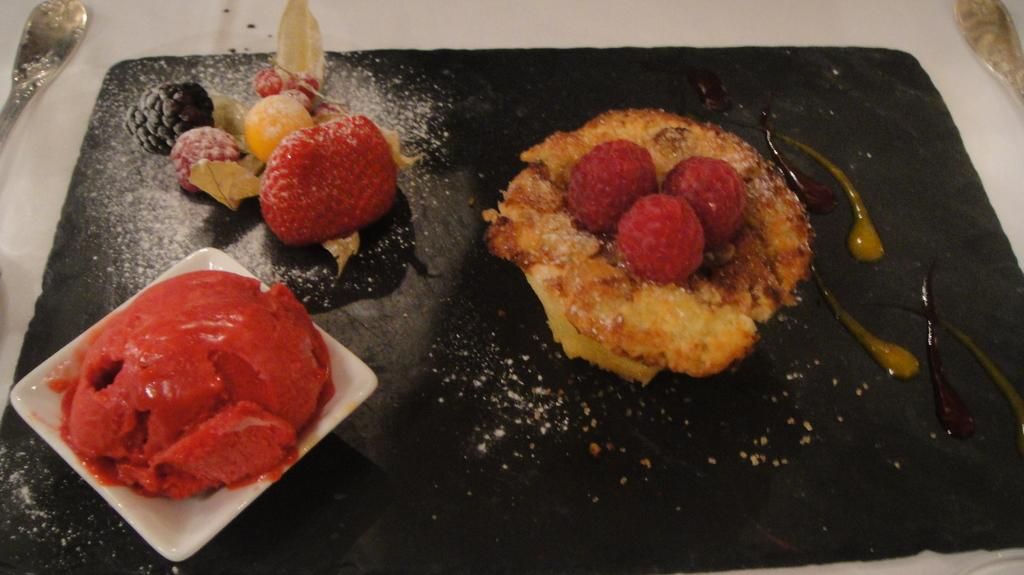What types of items can be seen in the image? There are edible items in the image. Can you describe the arrangement of these items? There are two objects on either side of the edible items. Can you tell me how many frogs are sitting on the edible items in the image? There are no frogs present in the image. What color is the memory card in the image? There is no mention of a memory card or any electronic device in the image. 